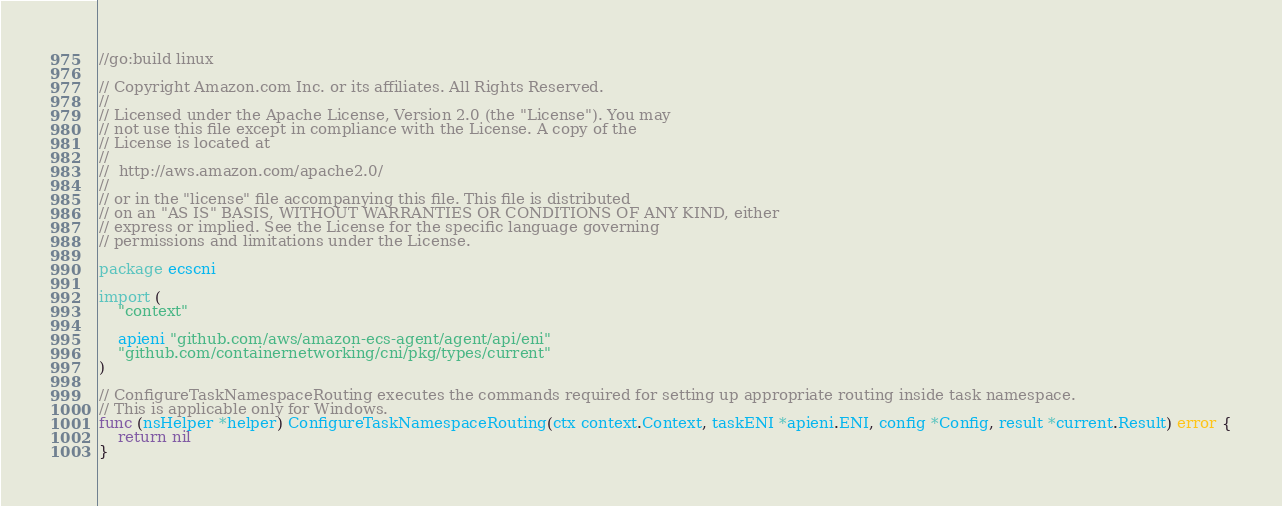<code> <loc_0><loc_0><loc_500><loc_500><_Go_>//go:build linux

// Copyright Amazon.com Inc. or its affiliates. All Rights Reserved.
//
// Licensed under the Apache License, Version 2.0 (the "License"). You may
// not use this file except in compliance with the License. A copy of the
// License is located at
//
//	http://aws.amazon.com/apache2.0/
//
// or in the "license" file accompanying this file. This file is distributed
// on an "AS IS" BASIS, WITHOUT WARRANTIES OR CONDITIONS OF ANY KIND, either
// express or implied. See the License for the specific language governing
// permissions and limitations under the License.

package ecscni

import (
	"context"

	apieni "github.com/aws/amazon-ecs-agent/agent/api/eni"
	"github.com/containernetworking/cni/pkg/types/current"
)

// ConfigureTaskNamespaceRouting executes the commands required for setting up appropriate routing inside task namespace.
// This is applicable only for Windows.
func (nsHelper *helper) ConfigureTaskNamespaceRouting(ctx context.Context, taskENI *apieni.ENI, config *Config, result *current.Result) error {
	return nil
}
</code> 